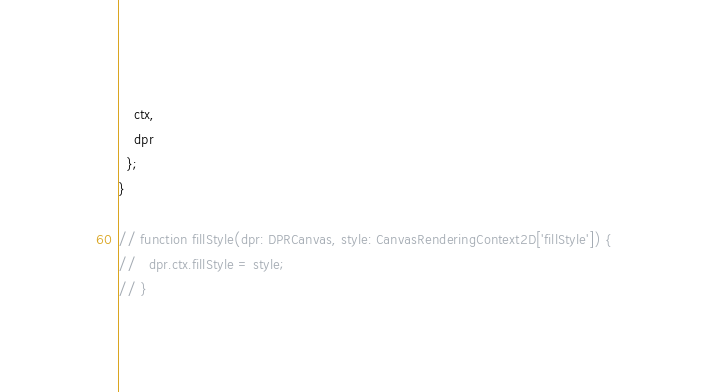<code> <loc_0><loc_0><loc_500><loc_500><_TypeScript_>    ctx,
    dpr
  };
}

// function fillStyle(dpr: DPRCanvas, style: CanvasRenderingContext2D['fillStyle']) {
//   dpr.ctx.fillStyle = style;
// }
</code> 